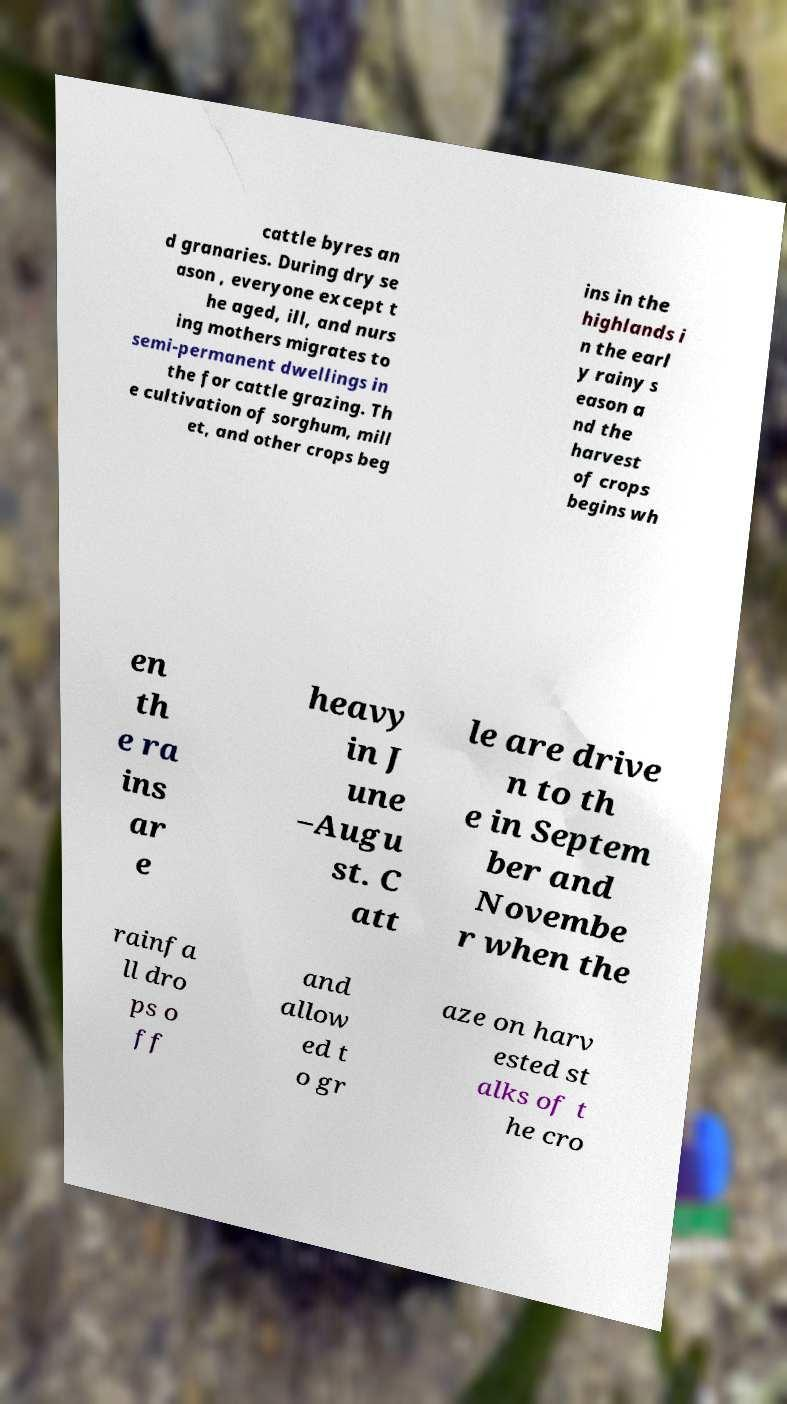Could you extract and type out the text from this image? cattle byres an d granaries. During dry se ason , everyone except t he aged, ill, and nurs ing mothers migrates to semi-permanent dwellings in the for cattle grazing. Th e cultivation of sorghum, mill et, and other crops beg ins in the highlands i n the earl y rainy s eason a nd the harvest of crops begins wh en th e ra ins ar e heavy in J une –Augu st. C att le are drive n to th e in Septem ber and Novembe r when the rainfa ll dro ps o ff and allow ed t o gr aze on harv ested st alks of t he cro 